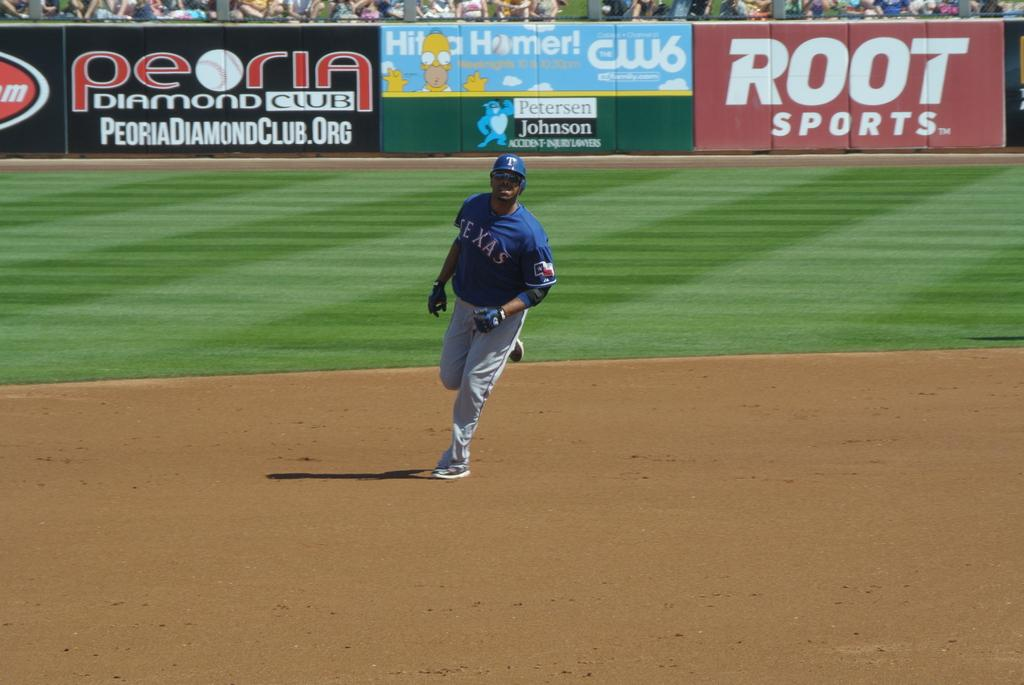<image>
Describe the image concisely. A Root Sports logo can be seen at a baseball field. 